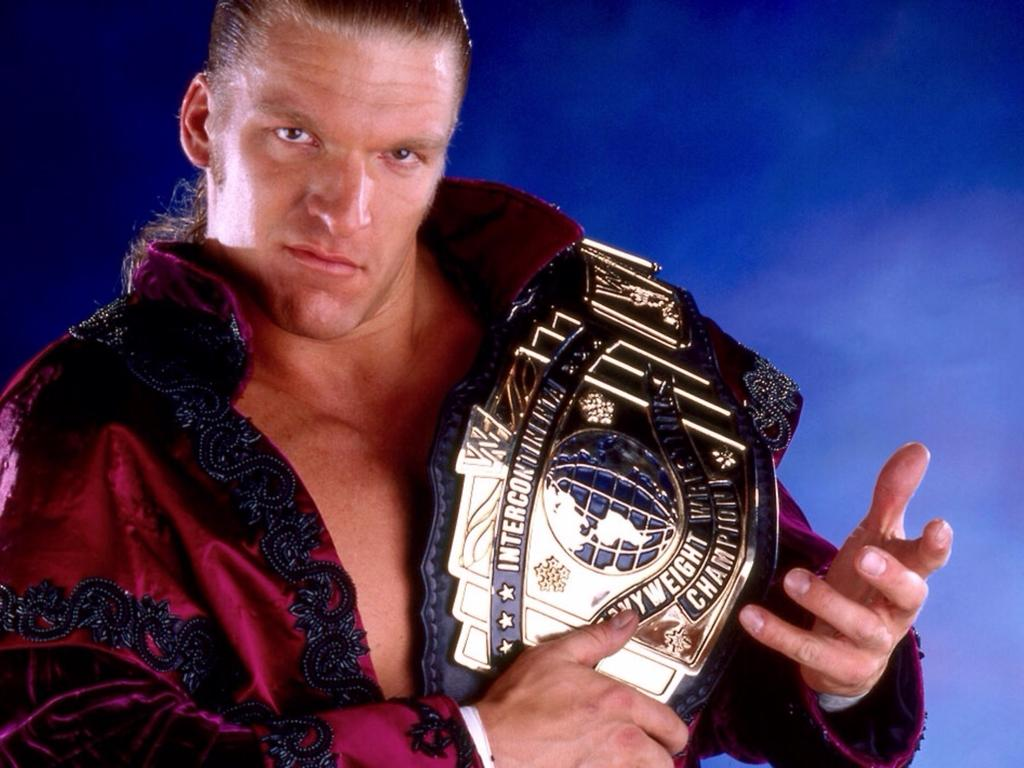<image>
Describe the image concisely. A man displays his Intercontinental Heavyweight Champion belt. 